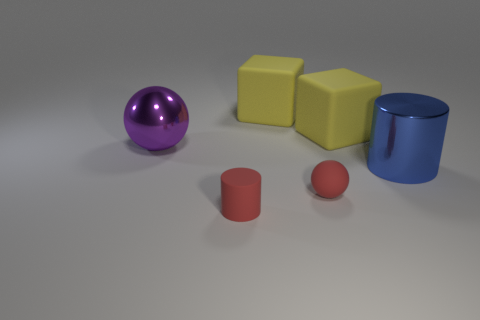Are there any other things of the same color as the tiny ball? Yes, the tiny red ball shares its color with the larger cylinder nearby. They both have a similar shade of red, which contrasts with the other objects in the scene that are yellow, blue, and purple. 